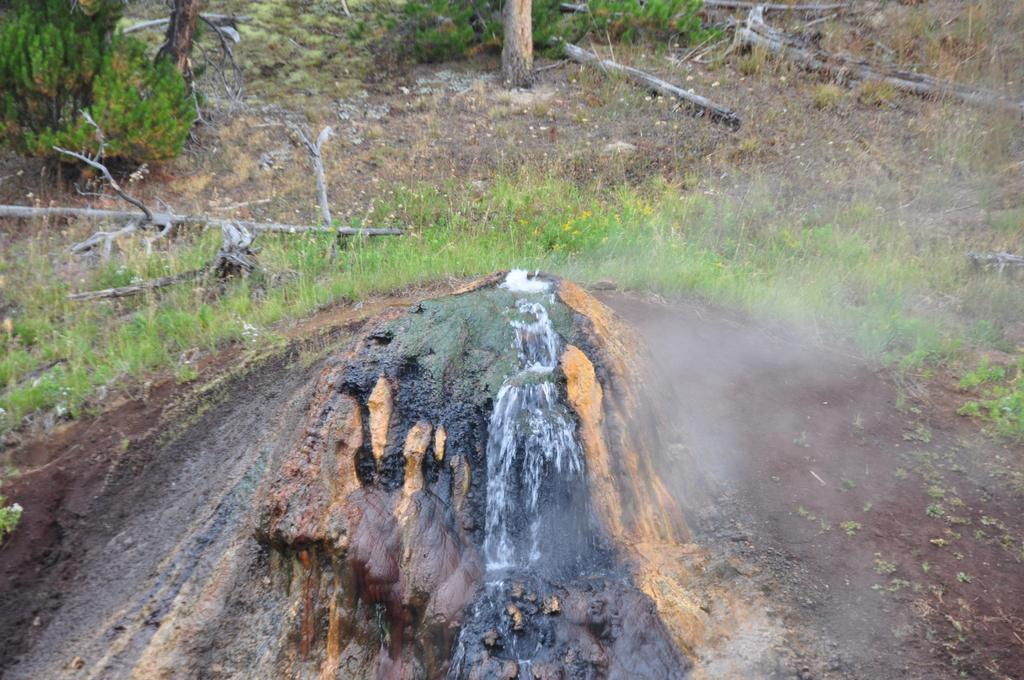What is the main subject in the center of the image? There is a rock in the center of the image. What can be seen in the background of the image? There are tree trunks in the background of the image. What type of vegetation is visible in the image? There is grass visible in the image. Can you find the receipt for the purchase of the bear in the image? There is no receipt or bear present in the image. 